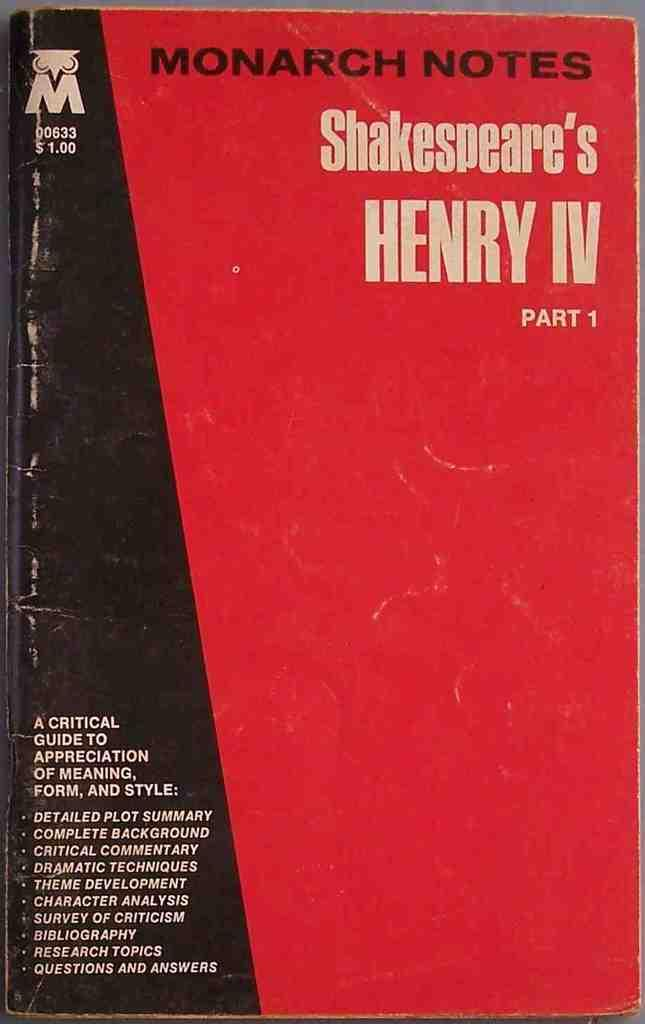Provide a one-sentence caption for the provided image. A red and black book is titled MONARCH NOTES Shakespeare's HENRY IV. 